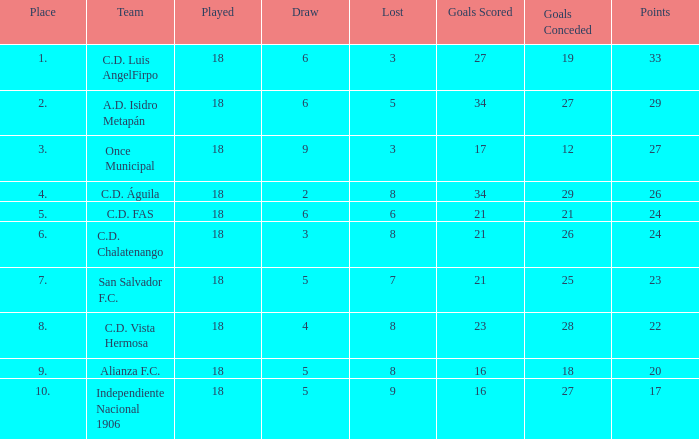How many points were in a game that had a lost of 5, greater than place 2, and 27 goals conceded? 0.0. 